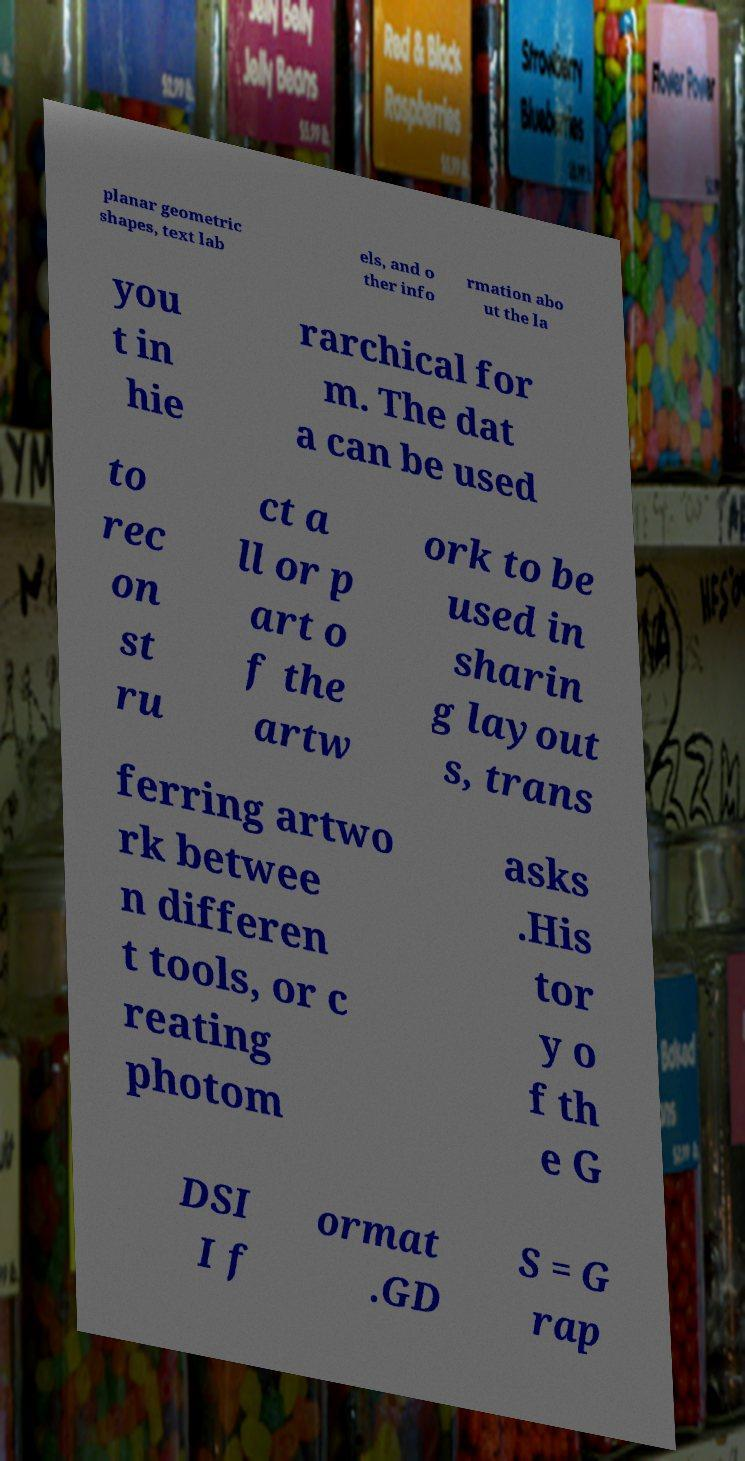Please read and relay the text visible in this image. What does it say? planar geometric shapes, text lab els, and o ther info rmation abo ut the la you t in hie rarchical for m. The dat a can be used to rec on st ru ct a ll or p art o f the artw ork to be used in sharin g layout s, trans ferring artwo rk betwee n differen t tools, or c reating photom asks .His tor y o f th e G DSI I f ormat .GD S = G rap 